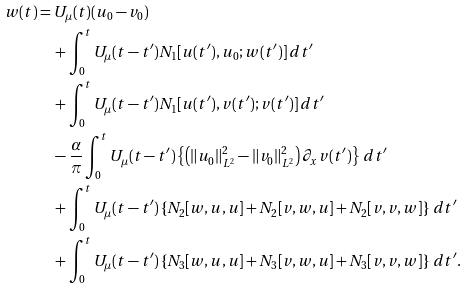<formula> <loc_0><loc_0><loc_500><loc_500>w ( t ) & = U _ { \mu } ( t ) ( u _ { 0 } - v _ { 0 } ) \\ & \quad + \int _ { 0 } ^ { t } U _ { \mu } ( t - t ^ { \prime } ) N _ { 1 } [ u ( t ^ { \prime } ) , u _ { 0 } ; w ( t ^ { \prime } ) ] \, d t ^ { \prime } \\ & \quad + \int _ { 0 } ^ { t } U _ { \mu } ( t - t ^ { \prime } ) N _ { 1 } [ u ( t ^ { \prime } ) , v ( t ^ { \prime } ) ; v ( t ^ { \prime } ) ] \, d t ^ { \prime } \\ & \quad - \frac { \alpha } { \pi } \int _ { 0 } ^ { t } U _ { \mu } ( t - t ^ { \prime } ) \left \{ \left ( \| u _ { 0 } \| _ { L ^ { 2 } } ^ { 2 } - \| v _ { 0 } \| _ { L ^ { 2 } } ^ { 2 } \right ) \partial _ { x } v ( t ^ { \prime } ) \right \} \, d t ^ { \prime } \\ & \quad + \int _ { 0 } ^ { t } U _ { \mu } ( t - t ^ { \prime } ) \left \{ N _ { 2 } [ w , u , u ] + N _ { 2 } [ v , w , u ] + N _ { 2 } [ v , v , w ] \right \} \, d t ^ { \prime } \\ & \quad + \int _ { 0 } ^ { t } U _ { \mu } ( t - t ^ { \prime } ) \left \{ N _ { 3 } [ w , u , u ] + N _ { 3 } [ v , w , u ] + N _ { 3 } [ v , v , w ] \right \} \, d t ^ { \prime } .</formula> 